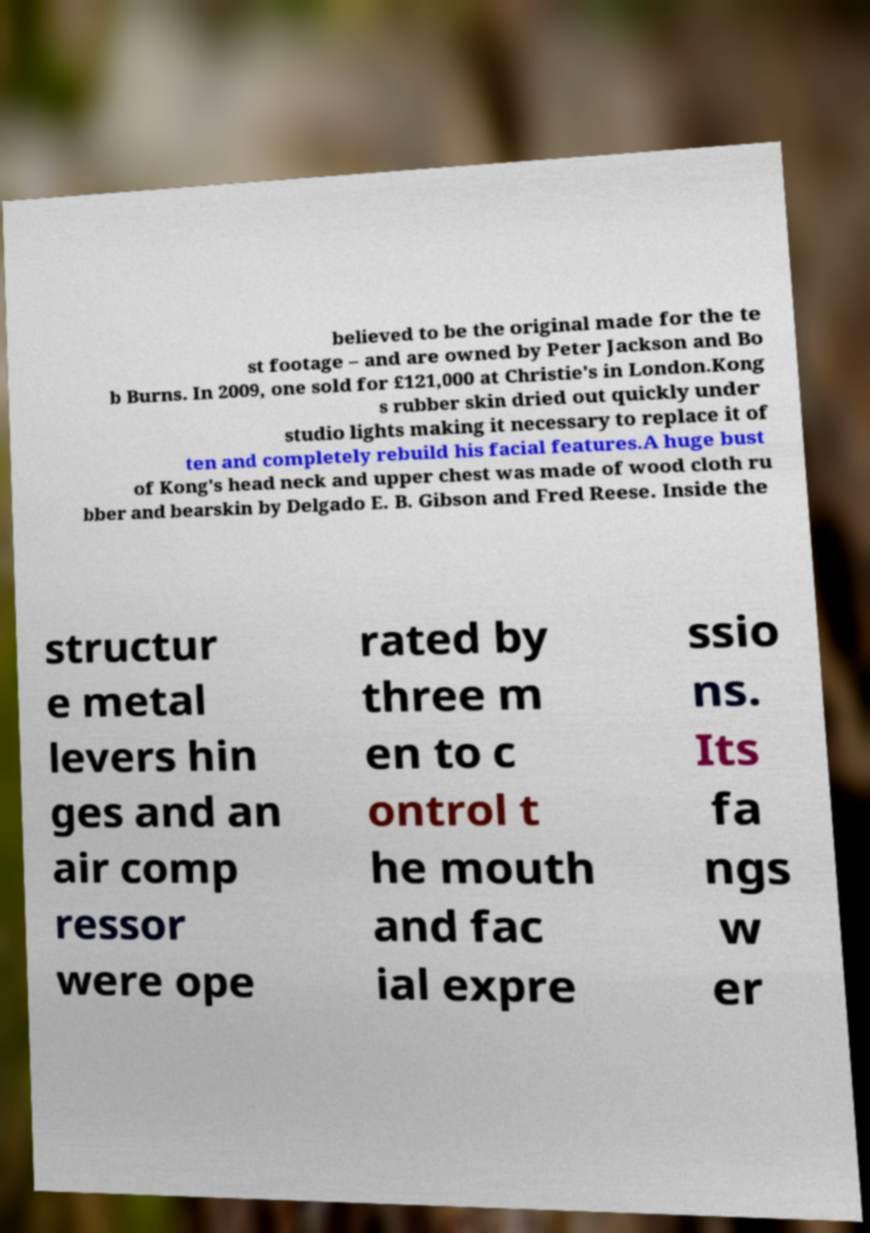What messages or text are displayed in this image? I need them in a readable, typed format. believed to be the original made for the te st footage – and are owned by Peter Jackson and Bo b Burns. In 2009, one sold for £121,000 at Christie's in London.Kong s rubber skin dried out quickly under studio lights making it necessary to replace it of ten and completely rebuild his facial features.A huge bust of Kong's head neck and upper chest was made of wood cloth ru bber and bearskin by Delgado E. B. Gibson and Fred Reese. Inside the structur e metal levers hin ges and an air comp ressor were ope rated by three m en to c ontrol t he mouth and fac ial expre ssio ns. Its fa ngs w er 